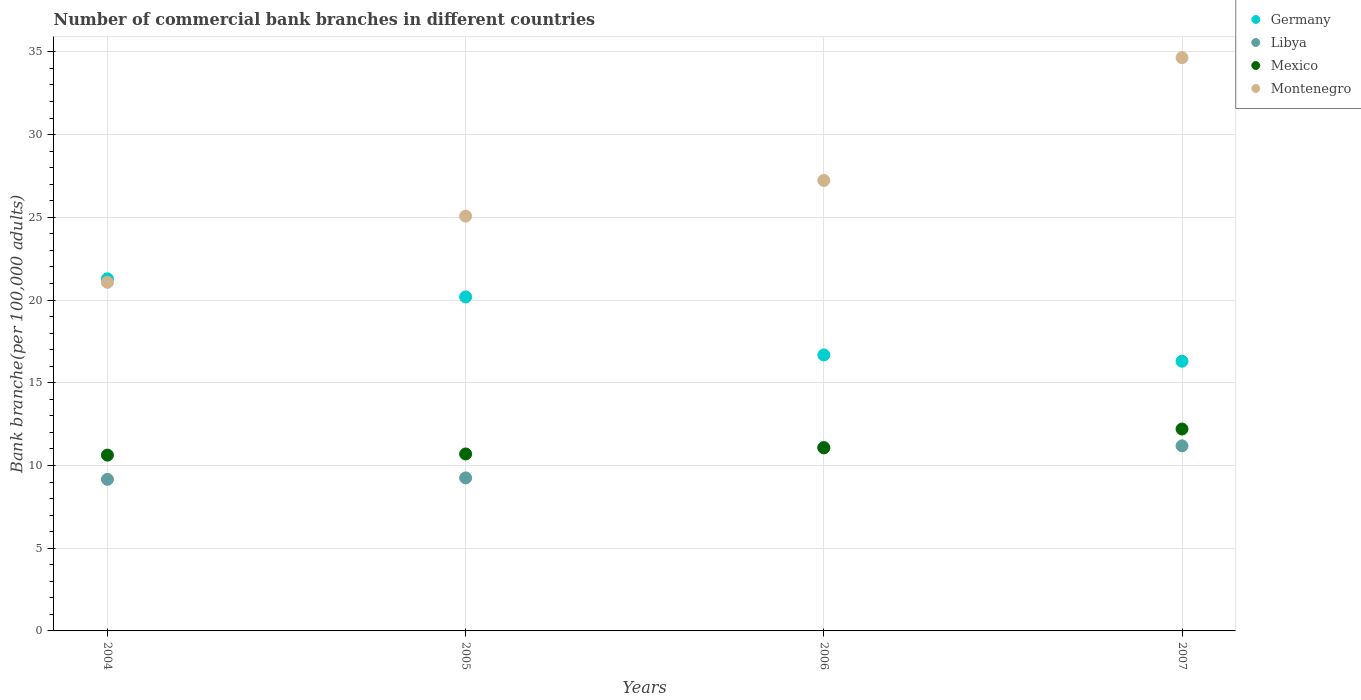How many different coloured dotlines are there?
Ensure brevity in your answer.  4. What is the number of commercial bank branches in Mexico in 2006?
Your answer should be very brief. 11.06. Across all years, what is the maximum number of commercial bank branches in Mexico?
Your answer should be compact. 12.2. Across all years, what is the minimum number of commercial bank branches in Libya?
Provide a succinct answer. 9.16. In which year was the number of commercial bank branches in Mexico maximum?
Offer a very short reply. 2007. In which year was the number of commercial bank branches in Germany minimum?
Ensure brevity in your answer.  2007. What is the total number of commercial bank branches in Libya in the graph?
Give a very brief answer. 40.7. What is the difference between the number of commercial bank branches in Germany in 2004 and that in 2006?
Provide a succinct answer. 4.6. What is the difference between the number of commercial bank branches in Germany in 2006 and the number of commercial bank branches in Mexico in 2004?
Give a very brief answer. 6.06. What is the average number of commercial bank branches in Germany per year?
Offer a very short reply. 18.61. In the year 2004, what is the difference between the number of commercial bank branches in Montenegro and number of commercial bank branches in Mexico?
Ensure brevity in your answer.  10.44. In how many years, is the number of commercial bank branches in Mexico greater than 31?
Your answer should be very brief. 0. What is the ratio of the number of commercial bank branches in Montenegro in 2006 to that in 2007?
Provide a succinct answer. 0.79. Is the number of commercial bank branches in Libya in 2006 less than that in 2007?
Offer a terse response. Yes. What is the difference between the highest and the second highest number of commercial bank branches in Libya?
Your response must be concise. 0.09. What is the difference between the highest and the lowest number of commercial bank branches in Libya?
Ensure brevity in your answer.  2.03. In how many years, is the number of commercial bank branches in Libya greater than the average number of commercial bank branches in Libya taken over all years?
Ensure brevity in your answer.  2. Is the sum of the number of commercial bank branches in Mexico in 2004 and 2006 greater than the maximum number of commercial bank branches in Libya across all years?
Provide a short and direct response. Yes. Is it the case that in every year, the sum of the number of commercial bank branches in Mexico and number of commercial bank branches in Montenegro  is greater than the sum of number of commercial bank branches in Libya and number of commercial bank branches in Germany?
Keep it short and to the point. Yes. Is it the case that in every year, the sum of the number of commercial bank branches in Montenegro and number of commercial bank branches in Germany  is greater than the number of commercial bank branches in Mexico?
Ensure brevity in your answer.  Yes. Is the number of commercial bank branches in Libya strictly greater than the number of commercial bank branches in Germany over the years?
Your answer should be very brief. No. How many dotlines are there?
Make the answer very short. 4. How many years are there in the graph?
Offer a terse response. 4. What is the difference between two consecutive major ticks on the Y-axis?
Give a very brief answer. 5. Does the graph contain any zero values?
Make the answer very short. No. Does the graph contain grids?
Give a very brief answer. Yes. What is the title of the graph?
Keep it short and to the point. Number of commercial bank branches in different countries. Does "Finland" appear as one of the legend labels in the graph?
Your response must be concise. No. What is the label or title of the Y-axis?
Offer a terse response. Bank branche(per 100,0 adults). What is the Bank branche(per 100,000 adults) of Germany in 2004?
Give a very brief answer. 21.28. What is the Bank branche(per 100,000 adults) in Libya in 2004?
Provide a short and direct response. 9.16. What is the Bank branche(per 100,000 adults) of Mexico in 2004?
Keep it short and to the point. 10.63. What is the Bank branche(per 100,000 adults) in Montenegro in 2004?
Your response must be concise. 21.07. What is the Bank branche(per 100,000 adults) in Germany in 2005?
Your response must be concise. 20.19. What is the Bank branche(per 100,000 adults) in Libya in 2005?
Make the answer very short. 9.25. What is the Bank branche(per 100,000 adults) of Mexico in 2005?
Your response must be concise. 10.7. What is the Bank branche(per 100,000 adults) of Montenegro in 2005?
Keep it short and to the point. 25.07. What is the Bank branche(per 100,000 adults) in Germany in 2006?
Give a very brief answer. 16.68. What is the Bank branche(per 100,000 adults) in Libya in 2006?
Give a very brief answer. 11.1. What is the Bank branche(per 100,000 adults) in Mexico in 2006?
Offer a terse response. 11.06. What is the Bank branche(per 100,000 adults) of Montenegro in 2006?
Offer a very short reply. 27.23. What is the Bank branche(per 100,000 adults) of Germany in 2007?
Provide a succinct answer. 16.3. What is the Bank branche(per 100,000 adults) of Libya in 2007?
Your answer should be compact. 11.19. What is the Bank branche(per 100,000 adults) in Mexico in 2007?
Provide a short and direct response. 12.2. What is the Bank branche(per 100,000 adults) in Montenegro in 2007?
Your answer should be very brief. 34.65. Across all years, what is the maximum Bank branche(per 100,000 adults) in Germany?
Make the answer very short. 21.28. Across all years, what is the maximum Bank branche(per 100,000 adults) in Libya?
Provide a succinct answer. 11.19. Across all years, what is the maximum Bank branche(per 100,000 adults) in Mexico?
Your answer should be compact. 12.2. Across all years, what is the maximum Bank branche(per 100,000 adults) in Montenegro?
Provide a short and direct response. 34.65. Across all years, what is the minimum Bank branche(per 100,000 adults) in Germany?
Your answer should be compact. 16.3. Across all years, what is the minimum Bank branche(per 100,000 adults) in Libya?
Ensure brevity in your answer.  9.16. Across all years, what is the minimum Bank branche(per 100,000 adults) in Mexico?
Make the answer very short. 10.63. Across all years, what is the minimum Bank branche(per 100,000 adults) of Montenegro?
Ensure brevity in your answer.  21.07. What is the total Bank branche(per 100,000 adults) of Germany in the graph?
Give a very brief answer. 74.45. What is the total Bank branche(per 100,000 adults) in Libya in the graph?
Offer a very short reply. 40.7. What is the total Bank branche(per 100,000 adults) in Mexico in the graph?
Your answer should be compact. 44.59. What is the total Bank branche(per 100,000 adults) in Montenegro in the graph?
Ensure brevity in your answer.  108.02. What is the difference between the Bank branche(per 100,000 adults) in Germany in 2004 and that in 2005?
Offer a terse response. 1.09. What is the difference between the Bank branche(per 100,000 adults) of Libya in 2004 and that in 2005?
Your answer should be compact. -0.09. What is the difference between the Bank branche(per 100,000 adults) of Mexico in 2004 and that in 2005?
Provide a succinct answer. -0.07. What is the difference between the Bank branche(per 100,000 adults) in Montenegro in 2004 and that in 2005?
Ensure brevity in your answer.  -4. What is the difference between the Bank branche(per 100,000 adults) of Libya in 2004 and that in 2006?
Make the answer very short. -1.94. What is the difference between the Bank branche(per 100,000 adults) in Mexico in 2004 and that in 2006?
Ensure brevity in your answer.  -0.44. What is the difference between the Bank branche(per 100,000 adults) of Montenegro in 2004 and that in 2006?
Provide a short and direct response. -6.16. What is the difference between the Bank branche(per 100,000 adults) of Germany in 2004 and that in 2007?
Ensure brevity in your answer.  4.98. What is the difference between the Bank branche(per 100,000 adults) in Libya in 2004 and that in 2007?
Your response must be concise. -2.03. What is the difference between the Bank branche(per 100,000 adults) in Mexico in 2004 and that in 2007?
Give a very brief answer. -1.58. What is the difference between the Bank branche(per 100,000 adults) in Montenegro in 2004 and that in 2007?
Give a very brief answer. -13.58. What is the difference between the Bank branche(per 100,000 adults) of Germany in 2005 and that in 2006?
Provide a short and direct response. 3.51. What is the difference between the Bank branche(per 100,000 adults) in Libya in 2005 and that in 2006?
Ensure brevity in your answer.  -1.85. What is the difference between the Bank branche(per 100,000 adults) in Mexico in 2005 and that in 2006?
Offer a very short reply. -0.37. What is the difference between the Bank branche(per 100,000 adults) in Montenegro in 2005 and that in 2006?
Your answer should be very brief. -2.16. What is the difference between the Bank branche(per 100,000 adults) in Germany in 2005 and that in 2007?
Give a very brief answer. 3.89. What is the difference between the Bank branche(per 100,000 adults) in Libya in 2005 and that in 2007?
Provide a succinct answer. -1.94. What is the difference between the Bank branche(per 100,000 adults) in Mexico in 2005 and that in 2007?
Offer a terse response. -1.51. What is the difference between the Bank branche(per 100,000 adults) in Montenegro in 2005 and that in 2007?
Your response must be concise. -9.58. What is the difference between the Bank branche(per 100,000 adults) in Germany in 2006 and that in 2007?
Provide a short and direct response. 0.38. What is the difference between the Bank branche(per 100,000 adults) of Libya in 2006 and that in 2007?
Your answer should be compact. -0.09. What is the difference between the Bank branche(per 100,000 adults) in Mexico in 2006 and that in 2007?
Offer a very short reply. -1.14. What is the difference between the Bank branche(per 100,000 adults) in Montenegro in 2006 and that in 2007?
Keep it short and to the point. -7.42. What is the difference between the Bank branche(per 100,000 adults) of Germany in 2004 and the Bank branche(per 100,000 adults) of Libya in 2005?
Keep it short and to the point. 12.03. What is the difference between the Bank branche(per 100,000 adults) of Germany in 2004 and the Bank branche(per 100,000 adults) of Mexico in 2005?
Ensure brevity in your answer.  10.59. What is the difference between the Bank branche(per 100,000 adults) in Germany in 2004 and the Bank branche(per 100,000 adults) in Montenegro in 2005?
Ensure brevity in your answer.  -3.79. What is the difference between the Bank branche(per 100,000 adults) in Libya in 2004 and the Bank branche(per 100,000 adults) in Mexico in 2005?
Ensure brevity in your answer.  -1.53. What is the difference between the Bank branche(per 100,000 adults) in Libya in 2004 and the Bank branche(per 100,000 adults) in Montenegro in 2005?
Provide a succinct answer. -15.91. What is the difference between the Bank branche(per 100,000 adults) in Mexico in 2004 and the Bank branche(per 100,000 adults) in Montenegro in 2005?
Your answer should be compact. -14.44. What is the difference between the Bank branche(per 100,000 adults) in Germany in 2004 and the Bank branche(per 100,000 adults) in Libya in 2006?
Offer a very short reply. 10.19. What is the difference between the Bank branche(per 100,000 adults) in Germany in 2004 and the Bank branche(per 100,000 adults) in Mexico in 2006?
Keep it short and to the point. 10.22. What is the difference between the Bank branche(per 100,000 adults) of Germany in 2004 and the Bank branche(per 100,000 adults) of Montenegro in 2006?
Offer a very short reply. -5.95. What is the difference between the Bank branche(per 100,000 adults) of Libya in 2004 and the Bank branche(per 100,000 adults) of Mexico in 2006?
Make the answer very short. -1.9. What is the difference between the Bank branche(per 100,000 adults) in Libya in 2004 and the Bank branche(per 100,000 adults) in Montenegro in 2006?
Your response must be concise. -18.07. What is the difference between the Bank branche(per 100,000 adults) of Mexico in 2004 and the Bank branche(per 100,000 adults) of Montenegro in 2006?
Your response must be concise. -16.6. What is the difference between the Bank branche(per 100,000 adults) of Germany in 2004 and the Bank branche(per 100,000 adults) of Libya in 2007?
Provide a short and direct response. 10.1. What is the difference between the Bank branche(per 100,000 adults) of Germany in 2004 and the Bank branche(per 100,000 adults) of Mexico in 2007?
Offer a terse response. 9.08. What is the difference between the Bank branche(per 100,000 adults) in Germany in 2004 and the Bank branche(per 100,000 adults) in Montenegro in 2007?
Provide a succinct answer. -13.37. What is the difference between the Bank branche(per 100,000 adults) of Libya in 2004 and the Bank branche(per 100,000 adults) of Mexico in 2007?
Give a very brief answer. -3.04. What is the difference between the Bank branche(per 100,000 adults) in Libya in 2004 and the Bank branche(per 100,000 adults) in Montenegro in 2007?
Offer a terse response. -25.49. What is the difference between the Bank branche(per 100,000 adults) in Mexico in 2004 and the Bank branche(per 100,000 adults) in Montenegro in 2007?
Your response must be concise. -24.02. What is the difference between the Bank branche(per 100,000 adults) in Germany in 2005 and the Bank branche(per 100,000 adults) in Libya in 2006?
Keep it short and to the point. 9.09. What is the difference between the Bank branche(per 100,000 adults) in Germany in 2005 and the Bank branche(per 100,000 adults) in Mexico in 2006?
Your answer should be very brief. 9.12. What is the difference between the Bank branche(per 100,000 adults) in Germany in 2005 and the Bank branche(per 100,000 adults) in Montenegro in 2006?
Offer a terse response. -7.04. What is the difference between the Bank branche(per 100,000 adults) of Libya in 2005 and the Bank branche(per 100,000 adults) of Mexico in 2006?
Provide a succinct answer. -1.81. What is the difference between the Bank branche(per 100,000 adults) of Libya in 2005 and the Bank branche(per 100,000 adults) of Montenegro in 2006?
Keep it short and to the point. -17.98. What is the difference between the Bank branche(per 100,000 adults) of Mexico in 2005 and the Bank branche(per 100,000 adults) of Montenegro in 2006?
Provide a short and direct response. -16.53. What is the difference between the Bank branche(per 100,000 adults) in Germany in 2005 and the Bank branche(per 100,000 adults) in Libya in 2007?
Offer a very short reply. 9. What is the difference between the Bank branche(per 100,000 adults) of Germany in 2005 and the Bank branche(per 100,000 adults) of Mexico in 2007?
Provide a short and direct response. 7.99. What is the difference between the Bank branche(per 100,000 adults) of Germany in 2005 and the Bank branche(per 100,000 adults) of Montenegro in 2007?
Your response must be concise. -14.46. What is the difference between the Bank branche(per 100,000 adults) of Libya in 2005 and the Bank branche(per 100,000 adults) of Mexico in 2007?
Offer a terse response. -2.95. What is the difference between the Bank branche(per 100,000 adults) in Libya in 2005 and the Bank branche(per 100,000 adults) in Montenegro in 2007?
Keep it short and to the point. -25.4. What is the difference between the Bank branche(per 100,000 adults) of Mexico in 2005 and the Bank branche(per 100,000 adults) of Montenegro in 2007?
Offer a very short reply. -23.95. What is the difference between the Bank branche(per 100,000 adults) in Germany in 2006 and the Bank branche(per 100,000 adults) in Libya in 2007?
Provide a succinct answer. 5.5. What is the difference between the Bank branche(per 100,000 adults) in Germany in 2006 and the Bank branche(per 100,000 adults) in Mexico in 2007?
Provide a succinct answer. 4.48. What is the difference between the Bank branche(per 100,000 adults) in Germany in 2006 and the Bank branche(per 100,000 adults) in Montenegro in 2007?
Give a very brief answer. -17.97. What is the difference between the Bank branche(per 100,000 adults) of Libya in 2006 and the Bank branche(per 100,000 adults) of Mexico in 2007?
Your response must be concise. -1.11. What is the difference between the Bank branche(per 100,000 adults) of Libya in 2006 and the Bank branche(per 100,000 adults) of Montenegro in 2007?
Give a very brief answer. -23.55. What is the difference between the Bank branche(per 100,000 adults) in Mexico in 2006 and the Bank branche(per 100,000 adults) in Montenegro in 2007?
Your response must be concise. -23.59. What is the average Bank branche(per 100,000 adults) of Germany per year?
Provide a short and direct response. 18.61. What is the average Bank branche(per 100,000 adults) of Libya per year?
Offer a very short reply. 10.17. What is the average Bank branche(per 100,000 adults) of Mexico per year?
Ensure brevity in your answer.  11.15. What is the average Bank branche(per 100,000 adults) in Montenegro per year?
Keep it short and to the point. 27.01. In the year 2004, what is the difference between the Bank branche(per 100,000 adults) in Germany and Bank branche(per 100,000 adults) in Libya?
Provide a short and direct response. 12.12. In the year 2004, what is the difference between the Bank branche(per 100,000 adults) of Germany and Bank branche(per 100,000 adults) of Mexico?
Keep it short and to the point. 10.66. In the year 2004, what is the difference between the Bank branche(per 100,000 adults) in Germany and Bank branche(per 100,000 adults) in Montenegro?
Provide a short and direct response. 0.21. In the year 2004, what is the difference between the Bank branche(per 100,000 adults) in Libya and Bank branche(per 100,000 adults) in Mexico?
Give a very brief answer. -1.47. In the year 2004, what is the difference between the Bank branche(per 100,000 adults) in Libya and Bank branche(per 100,000 adults) in Montenegro?
Give a very brief answer. -11.91. In the year 2004, what is the difference between the Bank branche(per 100,000 adults) in Mexico and Bank branche(per 100,000 adults) in Montenegro?
Give a very brief answer. -10.44. In the year 2005, what is the difference between the Bank branche(per 100,000 adults) in Germany and Bank branche(per 100,000 adults) in Libya?
Offer a very short reply. 10.94. In the year 2005, what is the difference between the Bank branche(per 100,000 adults) in Germany and Bank branche(per 100,000 adults) in Mexico?
Your response must be concise. 9.49. In the year 2005, what is the difference between the Bank branche(per 100,000 adults) of Germany and Bank branche(per 100,000 adults) of Montenegro?
Keep it short and to the point. -4.88. In the year 2005, what is the difference between the Bank branche(per 100,000 adults) in Libya and Bank branche(per 100,000 adults) in Mexico?
Keep it short and to the point. -1.45. In the year 2005, what is the difference between the Bank branche(per 100,000 adults) of Libya and Bank branche(per 100,000 adults) of Montenegro?
Your answer should be very brief. -15.82. In the year 2005, what is the difference between the Bank branche(per 100,000 adults) in Mexico and Bank branche(per 100,000 adults) in Montenegro?
Your answer should be very brief. -14.38. In the year 2006, what is the difference between the Bank branche(per 100,000 adults) of Germany and Bank branche(per 100,000 adults) of Libya?
Give a very brief answer. 5.58. In the year 2006, what is the difference between the Bank branche(per 100,000 adults) in Germany and Bank branche(per 100,000 adults) in Mexico?
Make the answer very short. 5.62. In the year 2006, what is the difference between the Bank branche(per 100,000 adults) in Germany and Bank branche(per 100,000 adults) in Montenegro?
Ensure brevity in your answer.  -10.55. In the year 2006, what is the difference between the Bank branche(per 100,000 adults) in Libya and Bank branche(per 100,000 adults) in Mexico?
Offer a very short reply. 0.03. In the year 2006, what is the difference between the Bank branche(per 100,000 adults) of Libya and Bank branche(per 100,000 adults) of Montenegro?
Give a very brief answer. -16.13. In the year 2006, what is the difference between the Bank branche(per 100,000 adults) of Mexico and Bank branche(per 100,000 adults) of Montenegro?
Your answer should be compact. -16.17. In the year 2007, what is the difference between the Bank branche(per 100,000 adults) of Germany and Bank branche(per 100,000 adults) of Libya?
Give a very brief answer. 5.11. In the year 2007, what is the difference between the Bank branche(per 100,000 adults) of Germany and Bank branche(per 100,000 adults) of Mexico?
Provide a short and direct response. 4.1. In the year 2007, what is the difference between the Bank branche(per 100,000 adults) of Germany and Bank branche(per 100,000 adults) of Montenegro?
Make the answer very short. -18.35. In the year 2007, what is the difference between the Bank branche(per 100,000 adults) of Libya and Bank branche(per 100,000 adults) of Mexico?
Offer a very short reply. -1.02. In the year 2007, what is the difference between the Bank branche(per 100,000 adults) of Libya and Bank branche(per 100,000 adults) of Montenegro?
Offer a very short reply. -23.46. In the year 2007, what is the difference between the Bank branche(per 100,000 adults) of Mexico and Bank branche(per 100,000 adults) of Montenegro?
Provide a succinct answer. -22.45. What is the ratio of the Bank branche(per 100,000 adults) of Germany in 2004 to that in 2005?
Your answer should be compact. 1.05. What is the ratio of the Bank branche(per 100,000 adults) in Libya in 2004 to that in 2005?
Your answer should be compact. 0.99. What is the ratio of the Bank branche(per 100,000 adults) of Montenegro in 2004 to that in 2005?
Provide a short and direct response. 0.84. What is the ratio of the Bank branche(per 100,000 adults) of Germany in 2004 to that in 2006?
Your answer should be very brief. 1.28. What is the ratio of the Bank branche(per 100,000 adults) in Libya in 2004 to that in 2006?
Provide a short and direct response. 0.83. What is the ratio of the Bank branche(per 100,000 adults) of Mexico in 2004 to that in 2006?
Offer a very short reply. 0.96. What is the ratio of the Bank branche(per 100,000 adults) of Montenegro in 2004 to that in 2006?
Give a very brief answer. 0.77. What is the ratio of the Bank branche(per 100,000 adults) in Germany in 2004 to that in 2007?
Make the answer very short. 1.31. What is the ratio of the Bank branche(per 100,000 adults) in Libya in 2004 to that in 2007?
Your response must be concise. 0.82. What is the ratio of the Bank branche(per 100,000 adults) of Mexico in 2004 to that in 2007?
Keep it short and to the point. 0.87. What is the ratio of the Bank branche(per 100,000 adults) in Montenegro in 2004 to that in 2007?
Offer a terse response. 0.61. What is the ratio of the Bank branche(per 100,000 adults) in Germany in 2005 to that in 2006?
Ensure brevity in your answer.  1.21. What is the ratio of the Bank branche(per 100,000 adults) in Libya in 2005 to that in 2006?
Ensure brevity in your answer.  0.83. What is the ratio of the Bank branche(per 100,000 adults) in Mexico in 2005 to that in 2006?
Keep it short and to the point. 0.97. What is the ratio of the Bank branche(per 100,000 adults) of Montenegro in 2005 to that in 2006?
Your response must be concise. 0.92. What is the ratio of the Bank branche(per 100,000 adults) in Germany in 2005 to that in 2007?
Provide a succinct answer. 1.24. What is the ratio of the Bank branche(per 100,000 adults) in Libya in 2005 to that in 2007?
Provide a short and direct response. 0.83. What is the ratio of the Bank branche(per 100,000 adults) of Mexico in 2005 to that in 2007?
Make the answer very short. 0.88. What is the ratio of the Bank branche(per 100,000 adults) in Montenegro in 2005 to that in 2007?
Give a very brief answer. 0.72. What is the ratio of the Bank branche(per 100,000 adults) in Germany in 2006 to that in 2007?
Your answer should be compact. 1.02. What is the ratio of the Bank branche(per 100,000 adults) of Libya in 2006 to that in 2007?
Give a very brief answer. 0.99. What is the ratio of the Bank branche(per 100,000 adults) of Mexico in 2006 to that in 2007?
Your answer should be very brief. 0.91. What is the ratio of the Bank branche(per 100,000 adults) of Montenegro in 2006 to that in 2007?
Give a very brief answer. 0.79. What is the difference between the highest and the second highest Bank branche(per 100,000 adults) in Germany?
Your answer should be very brief. 1.09. What is the difference between the highest and the second highest Bank branche(per 100,000 adults) in Libya?
Provide a short and direct response. 0.09. What is the difference between the highest and the second highest Bank branche(per 100,000 adults) in Mexico?
Ensure brevity in your answer.  1.14. What is the difference between the highest and the second highest Bank branche(per 100,000 adults) in Montenegro?
Your response must be concise. 7.42. What is the difference between the highest and the lowest Bank branche(per 100,000 adults) of Germany?
Give a very brief answer. 4.98. What is the difference between the highest and the lowest Bank branche(per 100,000 adults) in Libya?
Make the answer very short. 2.03. What is the difference between the highest and the lowest Bank branche(per 100,000 adults) of Mexico?
Your answer should be very brief. 1.58. What is the difference between the highest and the lowest Bank branche(per 100,000 adults) in Montenegro?
Offer a very short reply. 13.58. 